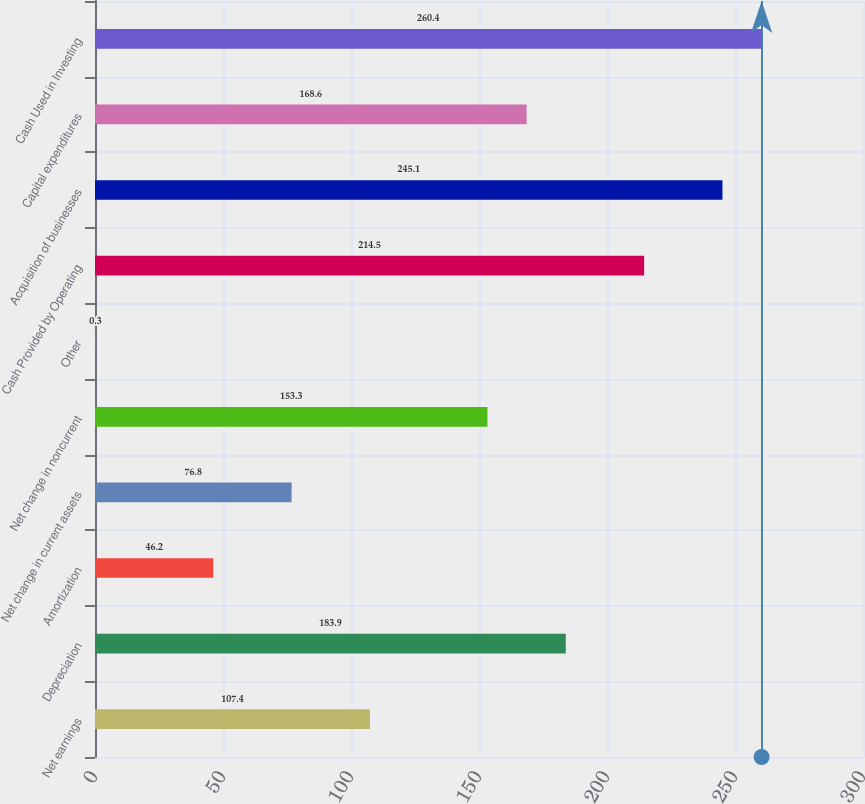Convert chart to OTSL. <chart><loc_0><loc_0><loc_500><loc_500><bar_chart><fcel>Net earnings<fcel>Depreciation<fcel>Amortization<fcel>Net change in current assets<fcel>Net change in noncurrent<fcel>Other<fcel>Cash Provided by Operating<fcel>Acquisition of businesses<fcel>Capital expenditures<fcel>Cash Used in Investing<nl><fcel>107.4<fcel>183.9<fcel>46.2<fcel>76.8<fcel>153.3<fcel>0.3<fcel>214.5<fcel>245.1<fcel>168.6<fcel>260.4<nl></chart> 